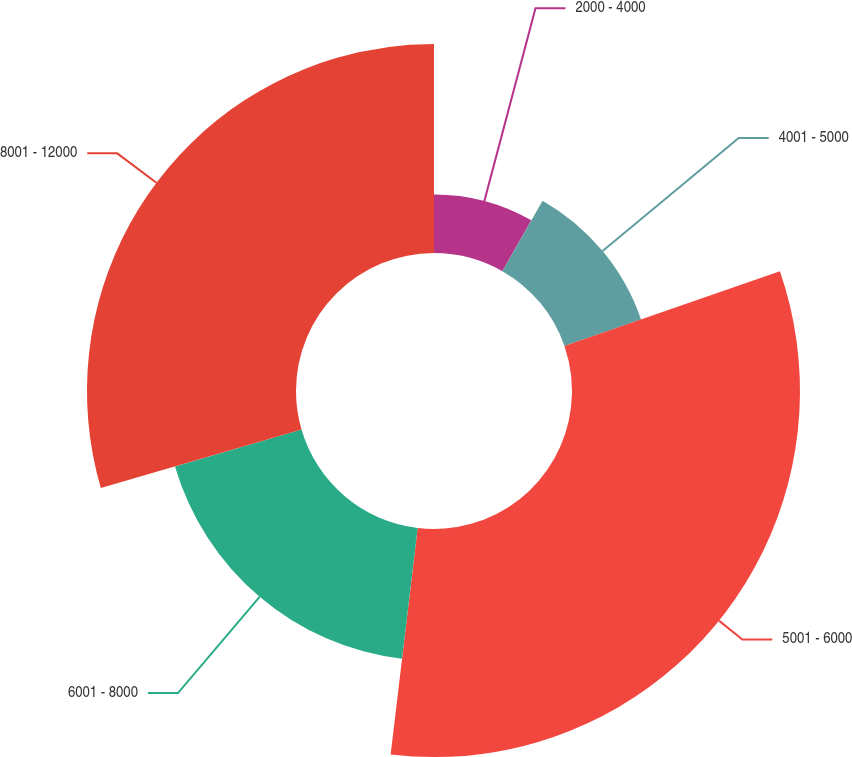Convert chart. <chart><loc_0><loc_0><loc_500><loc_500><pie_chart><fcel>2000 - 4000<fcel>4001 - 5000<fcel>5001 - 6000<fcel>6001 - 8000<fcel>8001 - 12000<nl><fcel>8.25%<fcel>11.45%<fcel>32.19%<fcel>18.6%<fcel>29.51%<nl></chart> 